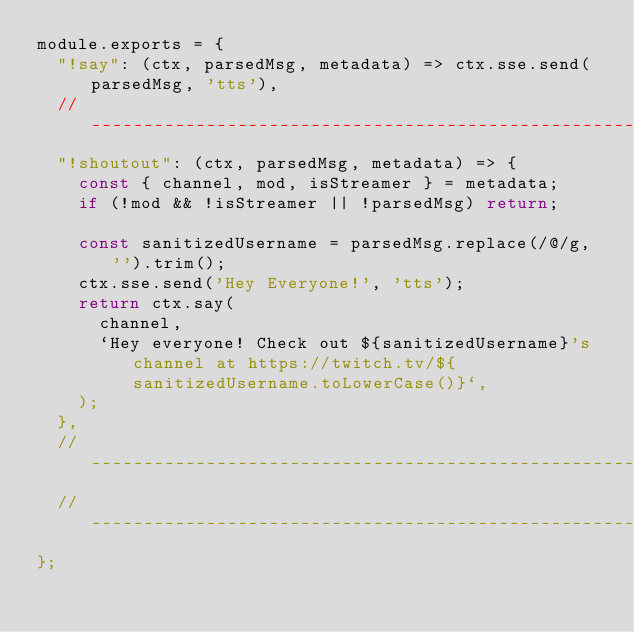<code> <loc_0><loc_0><loc_500><loc_500><_JavaScript_>module.exports = {
  "!say": (ctx, parsedMsg, metadata) => ctx.sse.send(parsedMsg, 'tts'),
  // -------------------------------------------------------------------------------------------------------
  "!shoutout": (ctx, parsedMsg, metadata) => {
    const { channel, mod, isStreamer } = metadata;
    if (!mod && !isStreamer || !parsedMsg) return;

    const sanitizedUsername = parsedMsg.replace(/@/g, '').trim();
    ctx.sse.send('Hey Everyone!', 'tts');
    return ctx.say(
      channel,
      `Hey everyone! Check out ${sanitizedUsername}'s channel at https://twitch.tv/${sanitizedUsername.toLowerCase()}`,
    );
  },
  // -------------------------------------------------------------------------------------------------------
  // -------------------------------------------------------------------------------------------------------
};
</code> 